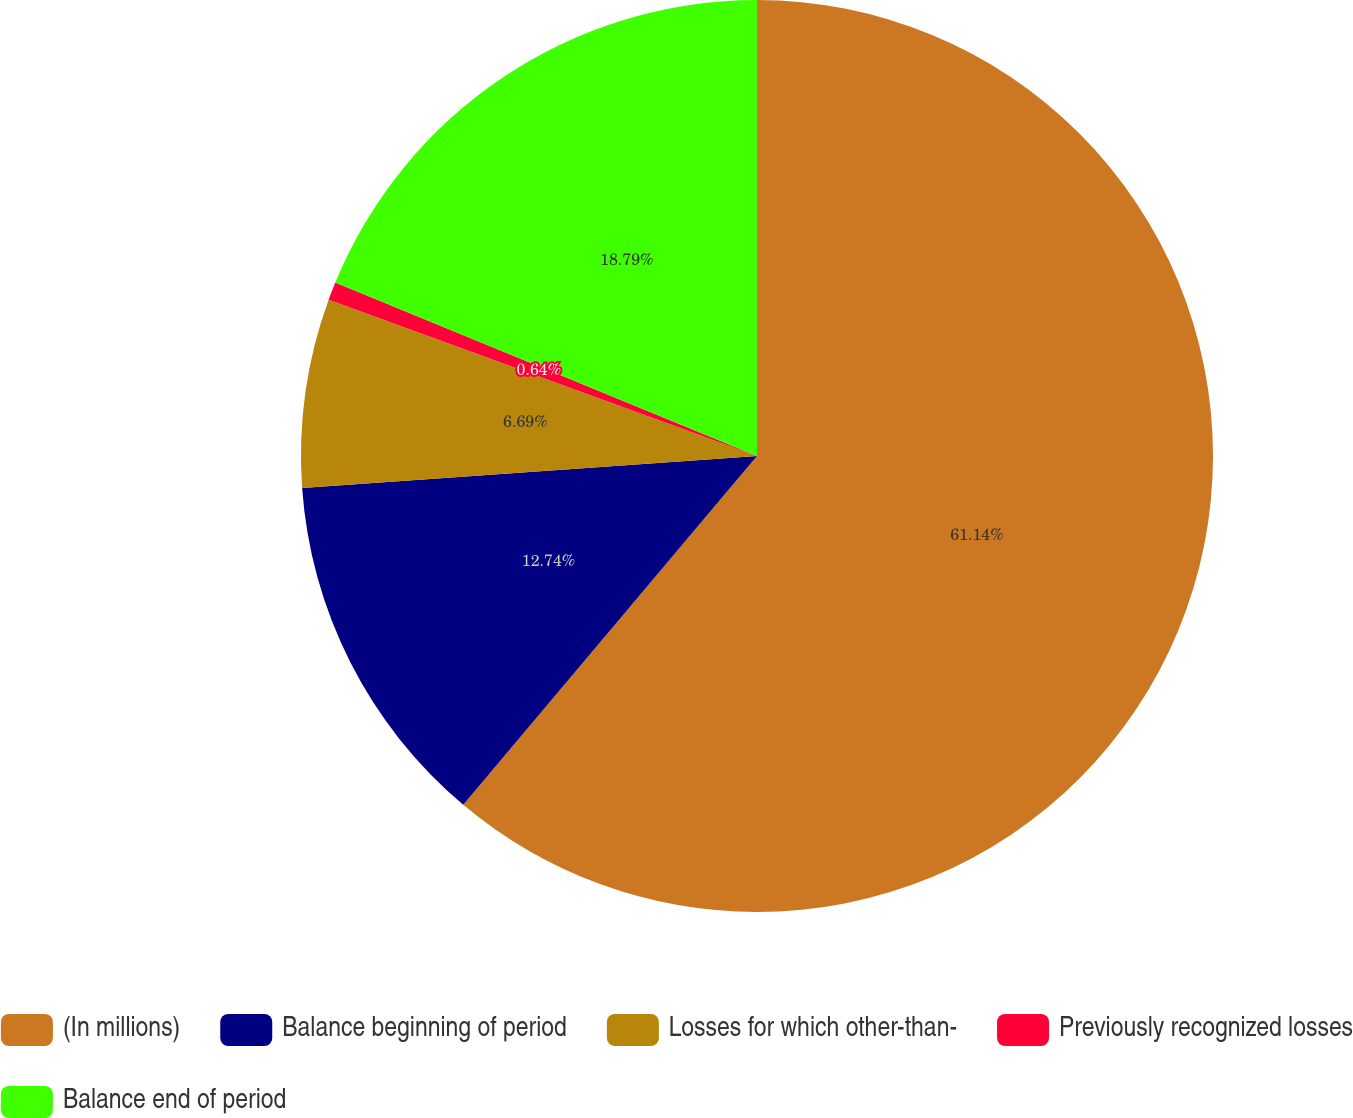<chart> <loc_0><loc_0><loc_500><loc_500><pie_chart><fcel>(In millions)<fcel>Balance beginning of period<fcel>Losses for which other-than-<fcel>Previously recognized losses<fcel>Balance end of period<nl><fcel>61.14%<fcel>12.74%<fcel>6.69%<fcel>0.64%<fcel>18.79%<nl></chart> 